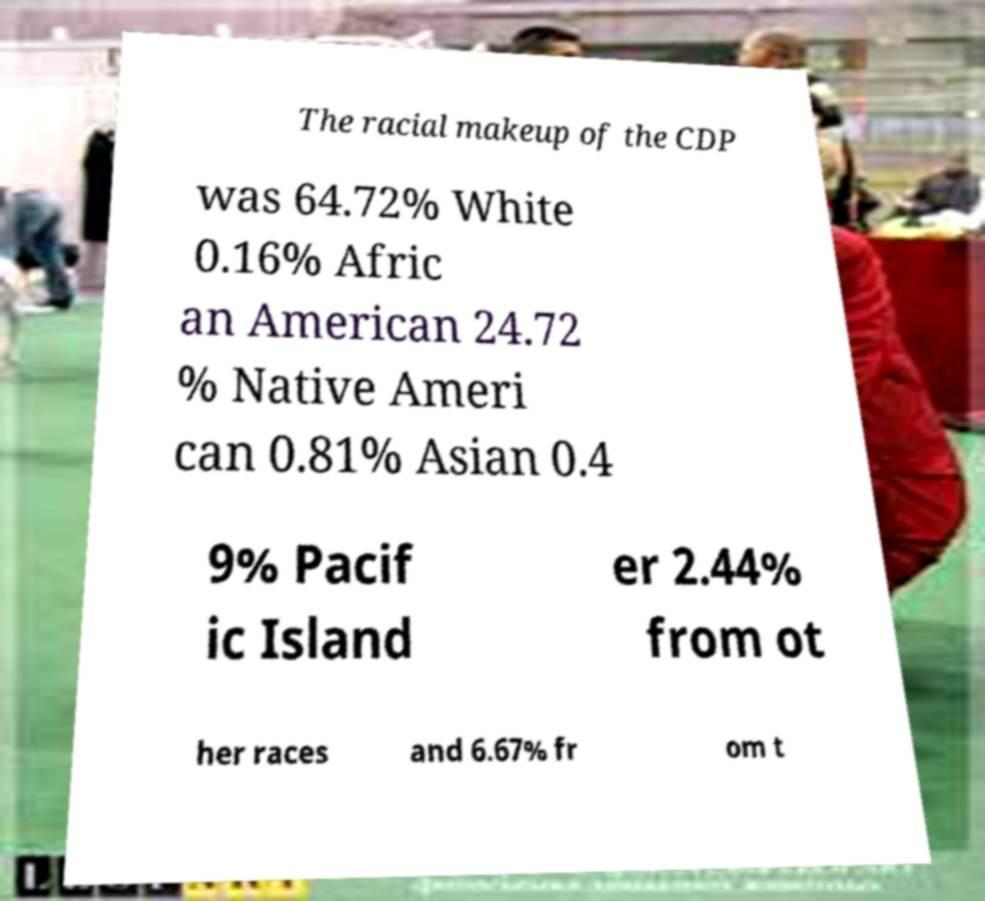What messages or text are displayed in this image? I need them in a readable, typed format. The racial makeup of the CDP was 64.72% White 0.16% Afric an American 24.72 % Native Ameri can 0.81% Asian 0.4 9% Pacif ic Island er 2.44% from ot her races and 6.67% fr om t 